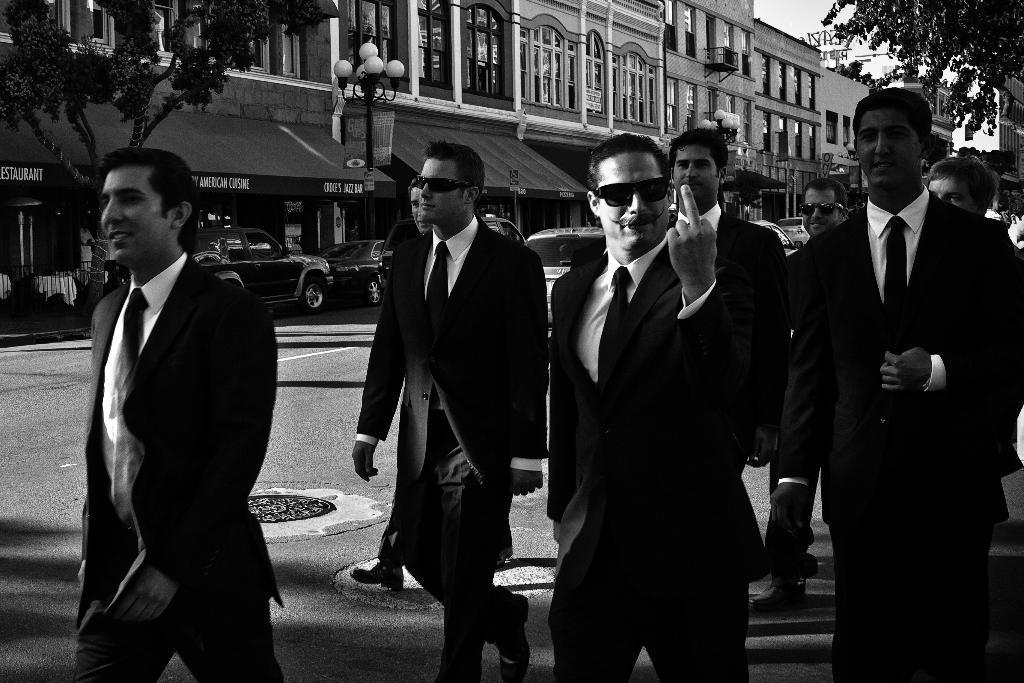Can you describe this image briefly? In the image we can see black and white picture of people walking, they are wearing clothes and some of them are wearing goggles. Here we can see the road and vehicles on the road, we can even see the building and the windows of the buildings. There are even trees, light poles and the sky. 